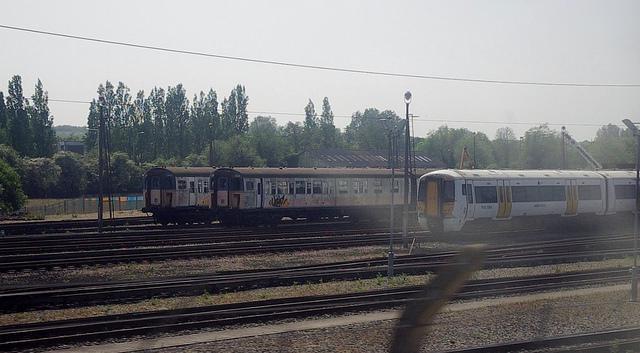How many trains are there?
Give a very brief answer. 3. How many people are in the photo?
Give a very brief answer. 0. 